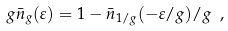<formula> <loc_0><loc_0><loc_500><loc_500>g \bar { n } _ { g } ( \varepsilon ) = 1 - \bar { n } _ { 1 / g } ( - \varepsilon / g ) / g \ ,</formula> 